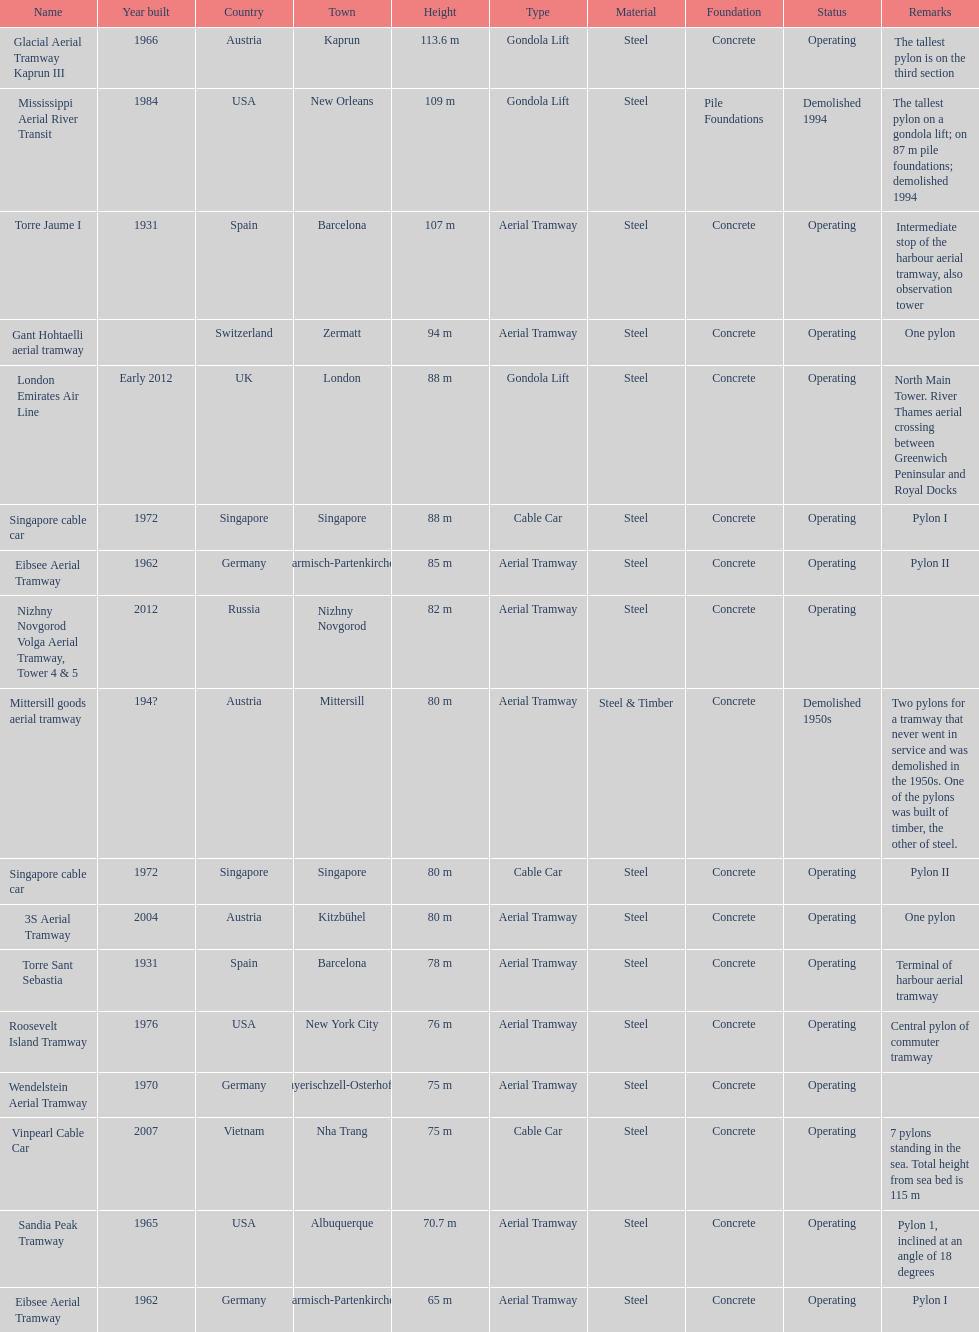Help me parse the entirety of this table. {'header': ['Name', 'Year built', 'Country', 'Town', 'Height', 'Type', 'Material', 'Foundation', 'Status', 'Remarks'], 'rows': [['Glacial Aerial Tramway Kaprun III', '1966', 'Austria', 'Kaprun', '113.6 m', 'Gondola Lift', 'Steel', 'Concrete', 'Operating', 'The tallest pylon is on the third section'], ['Mississippi Aerial River Transit', '1984', 'USA', 'New Orleans', '109 m', 'Gondola Lift', 'Steel', 'Pile Foundations', 'Demolished 1994', 'The tallest pylon on a gondola lift; on 87 m pile foundations; demolished 1994'], ['Torre Jaume I', '1931', 'Spain', 'Barcelona', '107 m', 'Aerial Tramway', 'Steel', 'Concrete', 'Operating', 'Intermediate stop of the harbour aerial tramway, also observation tower'], ['Gant Hohtaelli aerial tramway', '', 'Switzerland', 'Zermatt', '94 m', 'Aerial Tramway', 'Steel', 'Concrete', 'Operating', 'One pylon'], ['London Emirates Air Line', 'Early 2012', 'UK', 'London', '88 m', 'Gondola Lift', 'Steel', 'Concrete', 'Operating', 'North Main Tower. River Thames aerial crossing between Greenwich Peninsular and Royal Docks'], ['Singapore cable car', '1972', 'Singapore', 'Singapore', '88 m', 'Cable Car', 'Steel', 'Concrete', 'Operating', 'Pylon I'], ['Eibsee Aerial Tramway', '1962', 'Germany', 'Garmisch-Partenkirchen', '85 m', 'Aerial Tramway', 'Steel', 'Concrete', 'Operating', 'Pylon II'], ['Nizhny Novgorod Volga Aerial Tramway, Tower 4 & 5', '2012', 'Russia', 'Nizhny Novgorod', '82 m', 'Aerial Tramway', 'Steel', 'Concrete', 'Operating', ''], ['Mittersill goods aerial tramway', '194?', 'Austria', 'Mittersill', '80 m', 'Aerial Tramway', 'Steel & Timber', 'Concrete', 'Demolished 1950s', 'Two pylons for a tramway that never went in service and was demolished in the 1950s. One of the pylons was built of timber, the other of steel.'], ['Singapore cable car', '1972', 'Singapore', 'Singapore', '80 m', 'Cable Car', 'Steel', 'Concrete', 'Operating', 'Pylon II'], ['3S Aerial Tramway', '2004', 'Austria', 'Kitzbühel', '80 m', 'Aerial Tramway', 'Steel', 'Concrete', 'Operating', 'One pylon'], ['Torre Sant Sebastia', '1931', 'Spain', 'Barcelona', '78 m', 'Aerial Tramway', 'Steel', 'Concrete', 'Operating', 'Terminal of harbour aerial tramway'], ['Roosevelt Island Tramway', '1976', 'USA', 'New York City', '76 m', 'Aerial Tramway', 'Steel', 'Concrete', 'Operating', 'Central pylon of commuter tramway'], ['Wendelstein Aerial Tramway', '1970', 'Germany', 'Bayerischzell-Osterhofen', '75 m', 'Aerial Tramway', 'Steel', 'Concrete', 'Operating', ''], ['Vinpearl Cable Car', '2007', 'Vietnam', 'Nha Trang', '75 m', 'Cable Car', 'Steel', 'Concrete', 'Operating', '7 pylons standing in the sea. Total height from sea bed is 115 m'], ['Sandia Peak Tramway', '1965', 'USA', 'Albuquerque', '70.7 m', 'Aerial Tramway', 'Steel', 'Concrete', 'Operating', 'Pylon 1, inclined at an angle of 18 degrees'], ['Eibsee Aerial Tramway', '1962', 'Germany', 'Garmisch-Partenkirchen', '65 m', 'Aerial Tramway', 'Steel', 'Concrete', 'Operating', 'Pylon I']]} What year was the last pylon in germany built? 1970. 